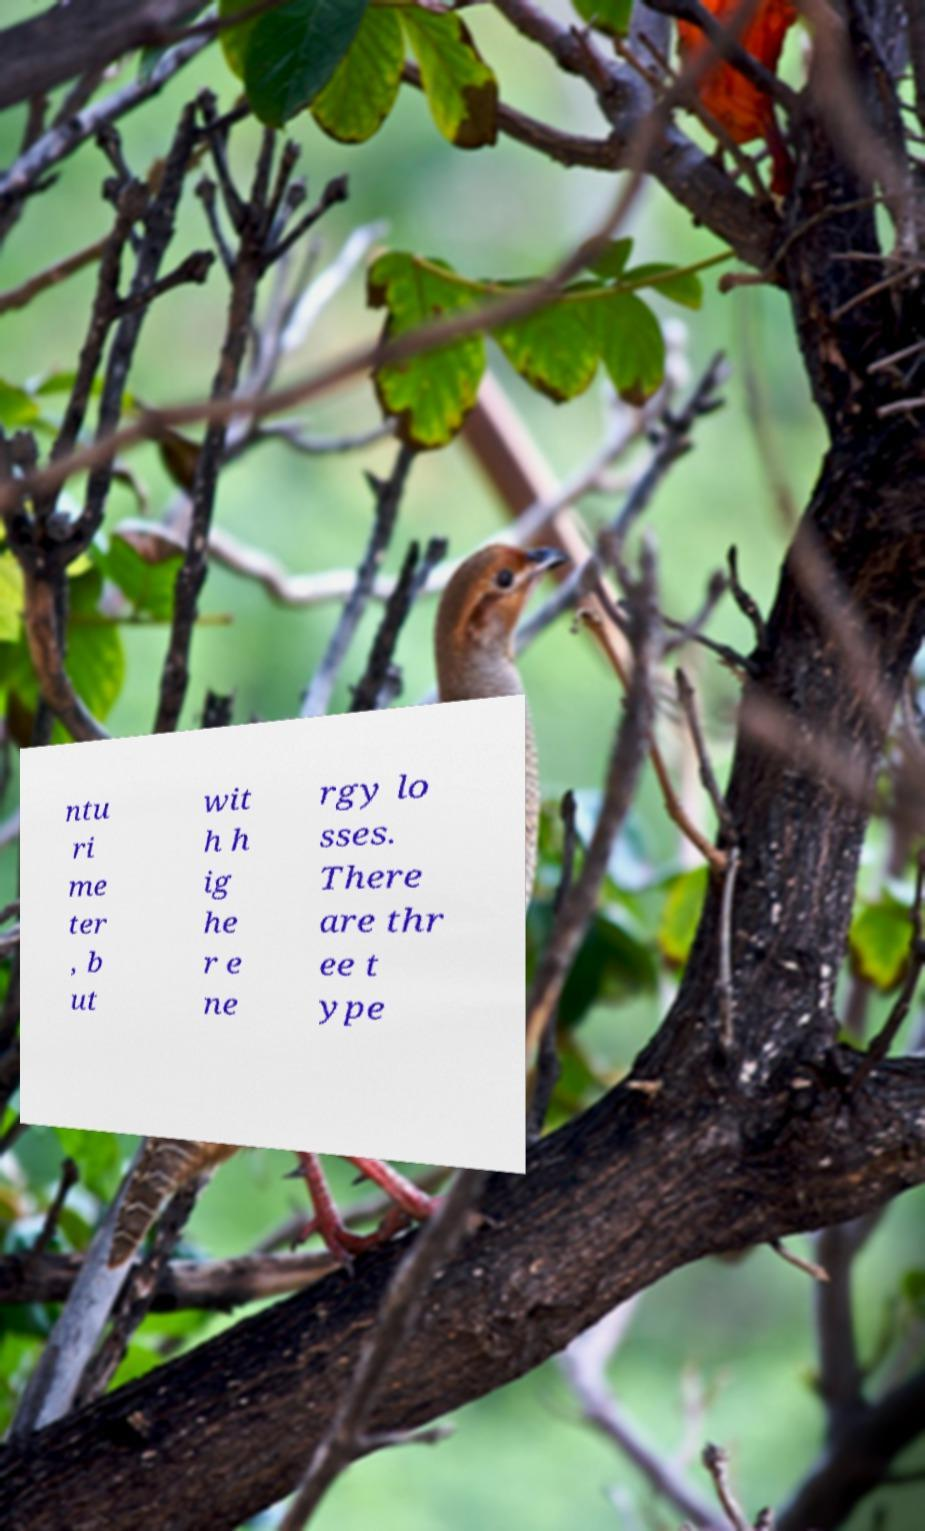There's text embedded in this image that I need extracted. Can you transcribe it verbatim? ntu ri me ter , b ut wit h h ig he r e ne rgy lo sses. There are thr ee t ype 